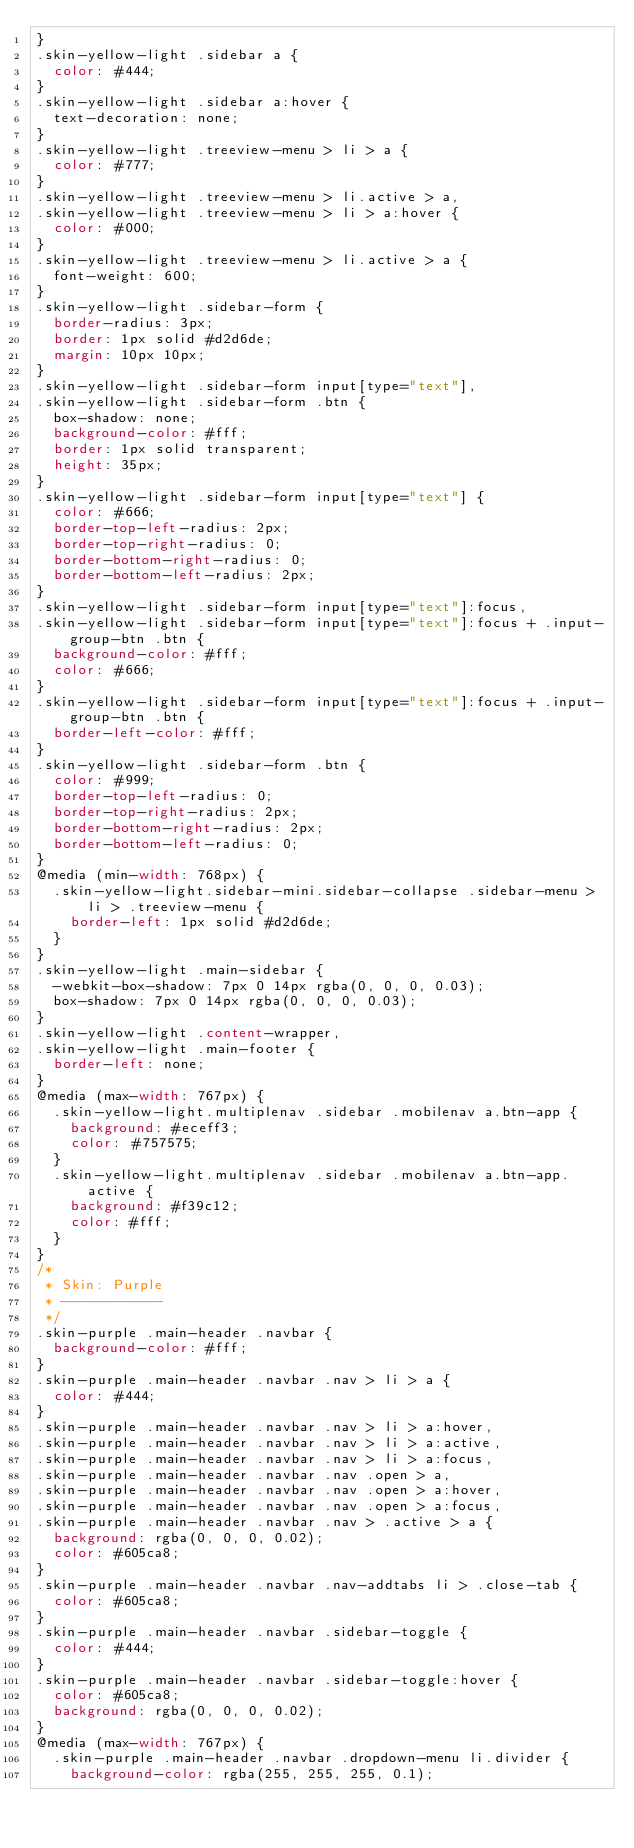Convert code to text. <code><loc_0><loc_0><loc_500><loc_500><_CSS_>}
.skin-yellow-light .sidebar a {
  color: #444;
}
.skin-yellow-light .sidebar a:hover {
  text-decoration: none;
}
.skin-yellow-light .treeview-menu > li > a {
  color: #777;
}
.skin-yellow-light .treeview-menu > li.active > a,
.skin-yellow-light .treeview-menu > li > a:hover {
  color: #000;
}
.skin-yellow-light .treeview-menu > li.active > a {
  font-weight: 600;
}
.skin-yellow-light .sidebar-form {
  border-radius: 3px;
  border: 1px solid #d2d6de;
  margin: 10px 10px;
}
.skin-yellow-light .sidebar-form input[type="text"],
.skin-yellow-light .sidebar-form .btn {
  box-shadow: none;
  background-color: #fff;
  border: 1px solid transparent;
  height: 35px;
}
.skin-yellow-light .sidebar-form input[type="text"] {
  color: #666;
  border-top-left-radius: 2px;
  border-top-right-radius: 0;
  border-bottom-right-radius: 0;
  border-bottom-left-radius: 2px;
}
.skin-yellow-light .sidebar-form input[type="text"]:focus,
.skin-yellow-light .sidebar-form input[type="text"]:focus + .input-group-btn .btn {
  background-color: #fff;
  color: #666;
}
.skin-yellow-light .sidebar-form input[type="text"]:focus + .input-group-btn .btn {
  border-left-color: #fff;
}
.skin-yellow-light .sidebar-form .btn {
  color: #999;
  border-top-left-radius: 0;
  border-top-right-radius: 2px;
  border-bottom-right-radius: 2px;
  border-bottom-left-radius: 0;
}
@media (min-width: 768px) {
  .skin-yellow-light.sidebar-mini.sidebar-collapse .sidebar-menu > li > .treeview-menu {
    border-left: 1px solid #d2d6de;
  }
}
.skin-yellow-light .main-sidebar {
  -webkit-box-shadow: 7px 0 14px rgba(0, 0, 0, 0.03);
  box-shadow: 7px 0 14px rgba(0, 0, 0, 0.03);
}
.skin-yellow-light .content-wrapper,
.skin-yellow-light .main-footer {
  border-left: none;
}
@media (max-width: 767px) {
  .skin-yellow-light.multiplenav .sidebar .mobilenav a.btn-app {
    background: #eceff3;
    color: #757575;
  }
  .skin-yellow-light.multiplenav .sidebar .mobilenav a.btn-app.active {
    background: #f39c12;
    color: #fff;
  }
}
/*
 * Skin: Purple
 * ------------
 */
.skin-purple .main-header .navbar {
  background-color: #fff;
}
.skin-purple .main-header .navbar .nav > li > a {
  color: #444;
}
.skin-purple .main-header .navbar .nav > li > a:hover,
.skin-purple .main-header .navbar .nav > li > a:active,
.skin-purple .main-header .navbar .nav > li > a:focus,
.skin-purple .main-header .navbar .nav .open > a,
.skin-purple .main-header .navbar .nav .open > a:hover,
.skin-purple .main-header .navbar .nav .open > a:focus,
.skin-purple .main-header .navbar .nav > .active > a {
  background: rgba(0, 0, 0, 0.02);
  color: #605ca8;
}
.skin-purple .main-header .navbar .nav-addtabs li > .close-tab {
  color: #605ca8;
}
.skin-purple .main-header .navbar .sidebar-toggle {
  color: #444;
}
.skin-purple .main-header .navbar .sidebar-toggle:hover {
  color: #605ca8;
  background: rgba(0, 0, 0, 0.02);
}
@media (max-width: 767px) {
  .skin-purple .main-header .navbar .dropdown-menu li.divider {
    background-color: rgba(255, 255, 255, 0.1);</code> 